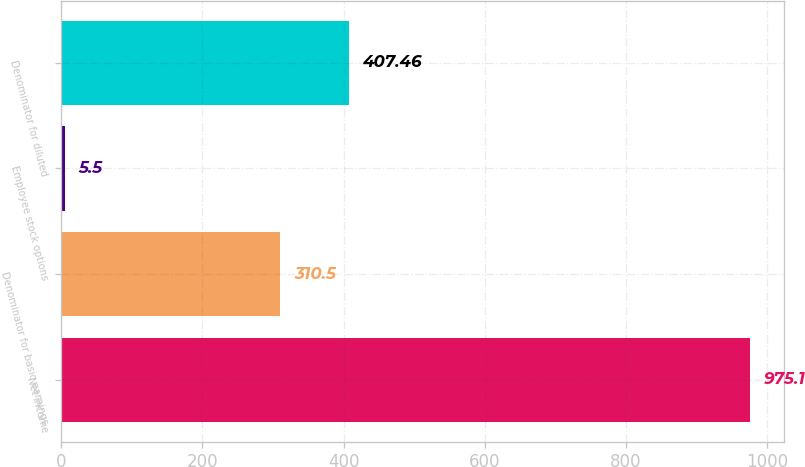Convert chart to OTSL. <chart><loc_0><loc_0><loc_500><loc_500><bar_chart><fcel>Net income<fcel>Denominator for basic earnings<fcel>Employee stock options<fcel>Denominator for diluted<nl><fcel>975.1<fcel>310.5<fcel>5.5<fcel>407.46<nl></chart> 